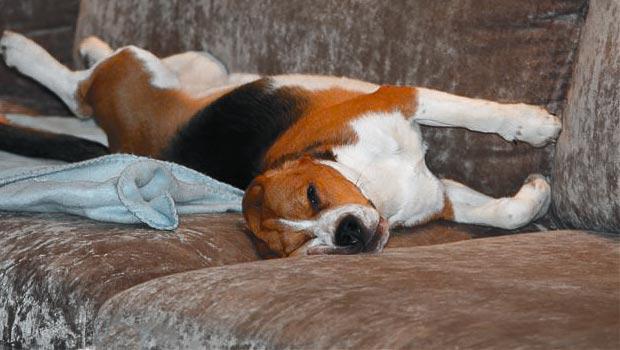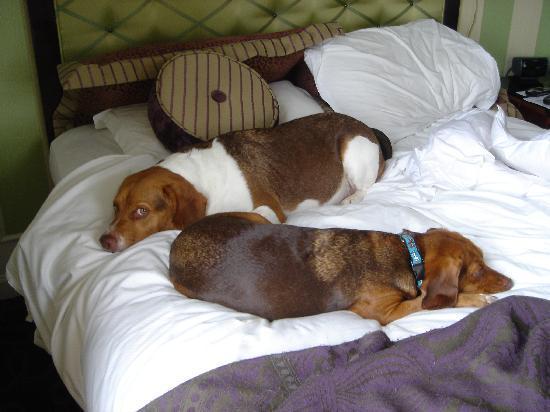The first image is the image on the left, the second image is the image on the right. For the images shown, is this caption "There is a one beagle in each picture, all sound asleep." true? Answer yes or no. No. The first image is the image on the left, the second image is the image on the right. Given the left and right images, does the statement "A dog is sleeping on a couch (sofa)." hold true? Answer yes or no. Yes. 